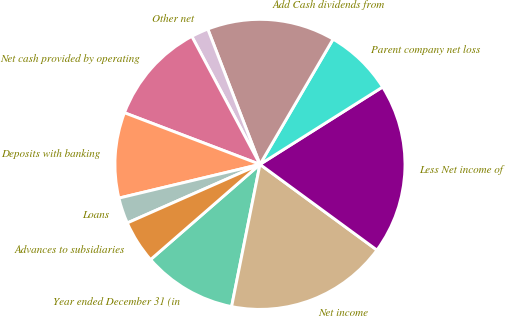Convert chart to OTSL. <chart><loc_0><loc_0><loc_500><loc_500><pie_chart><fcel>Year ended December 31 (in<fcel>Net income<fcel>Less Net income of<fcel>Parent company net loss<fcel>Add Cash dividends from<fcel>Other net<fcel>Net cash provided by operating<fcel>Deposits with banking<fcel>Loans<fcel>Advances to subsidiaries<nl><fcel>10.47%<fcel>18.07%<fcel>19.02%<fcel>7.63%<fcel>14.27%<fcel>1.93%<fcel>11.42%<fcel>9.53%<fcel>2.88%<fcel>4.78%<nl></chart> 